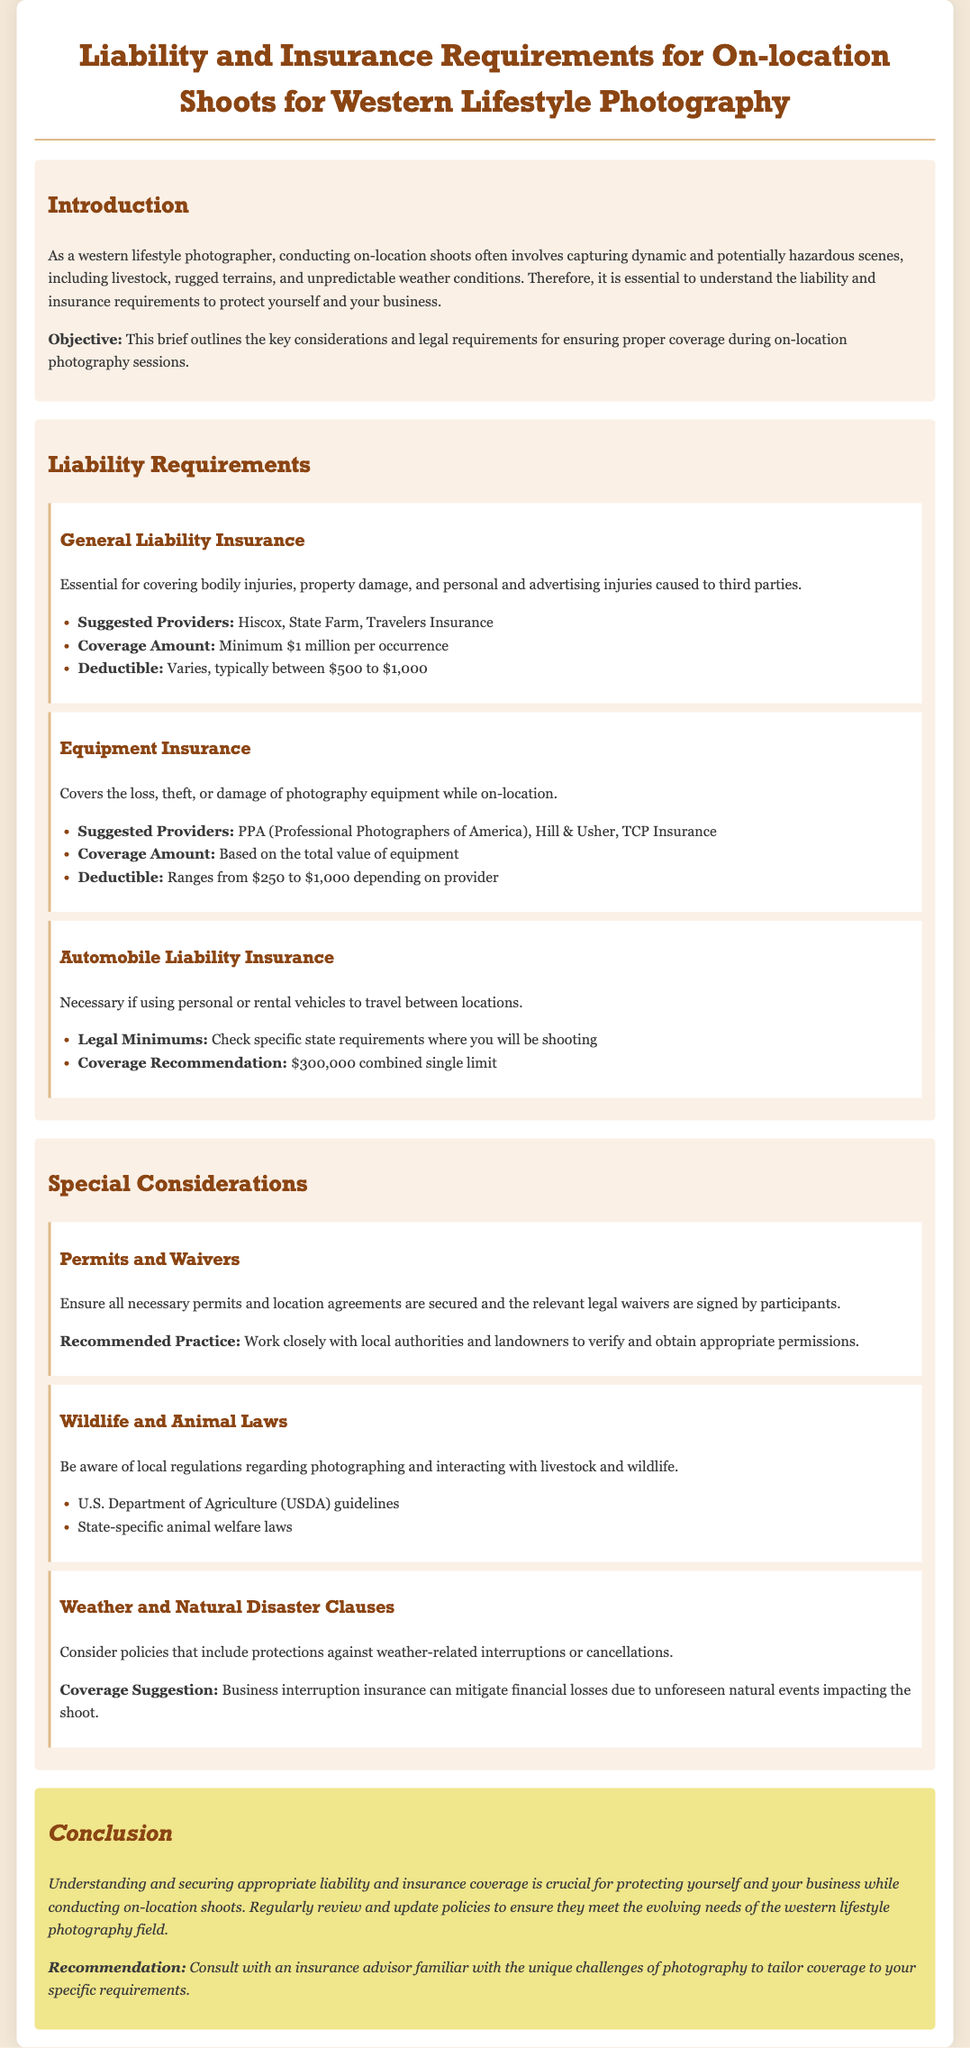What is the minimum coverage amount for general liability insurance? The document specifies that the minimum coverage amount for general liability insurance is $1 million per occurrence.
Answer: $1 million per occurrence Who are suggested providers for equipment insurance? The brief lists PPA (Professional Photographers of America), Hill & Usher, and TCP Insurance as suggested providers.
Answer: PPA (Professional Photographers of America), Hill & Usher, TCP Insurance What is the recommended coverage for automobile liability insurance? The document recommends a combined single limit of $300,000 for automobile liability insurance.
Answer: $300,000 combined single limit What type of insurance can mitigate financial losses due to unforeseen natural events? The document suggests business interruption insurance for mitigating financial losses from natural events impacting the shoot.
Answer: Business interruption insurance What should be secured and signed by participants according to the special considerations? The brief indicates that all necessary permits and location agreements should be secured and relevant legal waivers signed.
Answer: Permits and waivers What organization's guidelines should be followed for wildlife and animal laws? The document mentions that the U.S. Department of Agriculture (USDA) guidelines should be followed.
Answer: U.S. Department of Agriculture (USDA) What is the deductible range for equipment insurance? The document states that the deductible for equipment insurance ranges from $250 to $1,000 depending on the provider.
Answer: $250 to $1,000 What is the main objective of the brief? The document outlines that the objective is to describe the key considerations and legal requirements for coverage during on-location photography sessions.
Answer: Key considerations and legal requirements for coverage during on-location photography sessions 